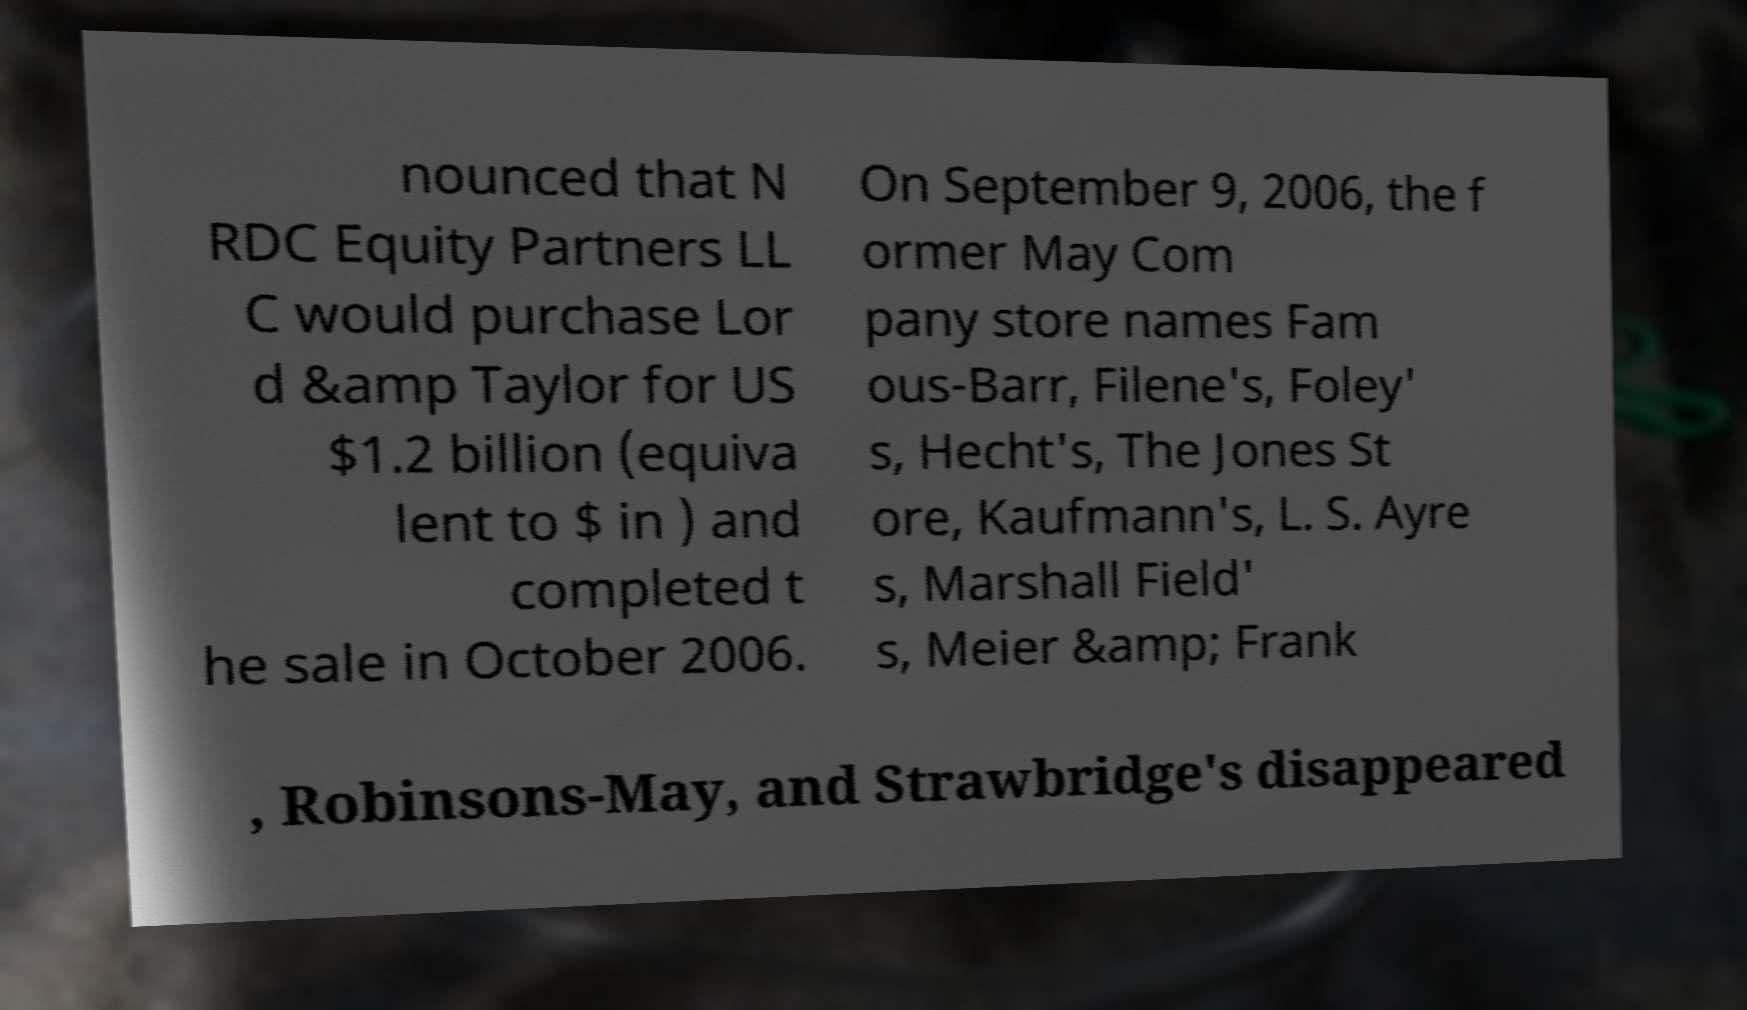Please identify and transcribe the text found in this image. nounced that N RDC Equity Partners LL C would purchase Lor d &amp Taylor for US $1.2 billion (equiva lent to $ in ) and completed t he sale in October 2006. On September 9, 2006, the f ormer May Com pany store names Fam ous-Barr, Filene's, Foley' s, Hecht's, The Jones St ore, Kaufmann's, L. S. Ayre s, Marshall Field' s, Meier &amp; Frank , Robinsons-May, and Strawbridge's disappeared 